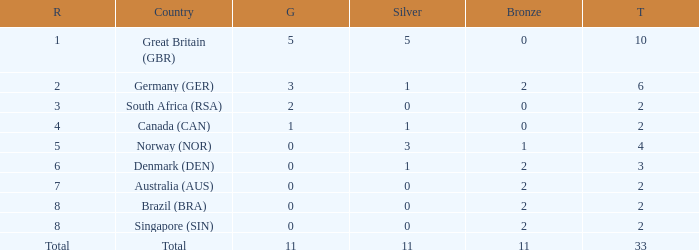What is the total when the nation is brazil (bra) and bronze is more than 2? None. 